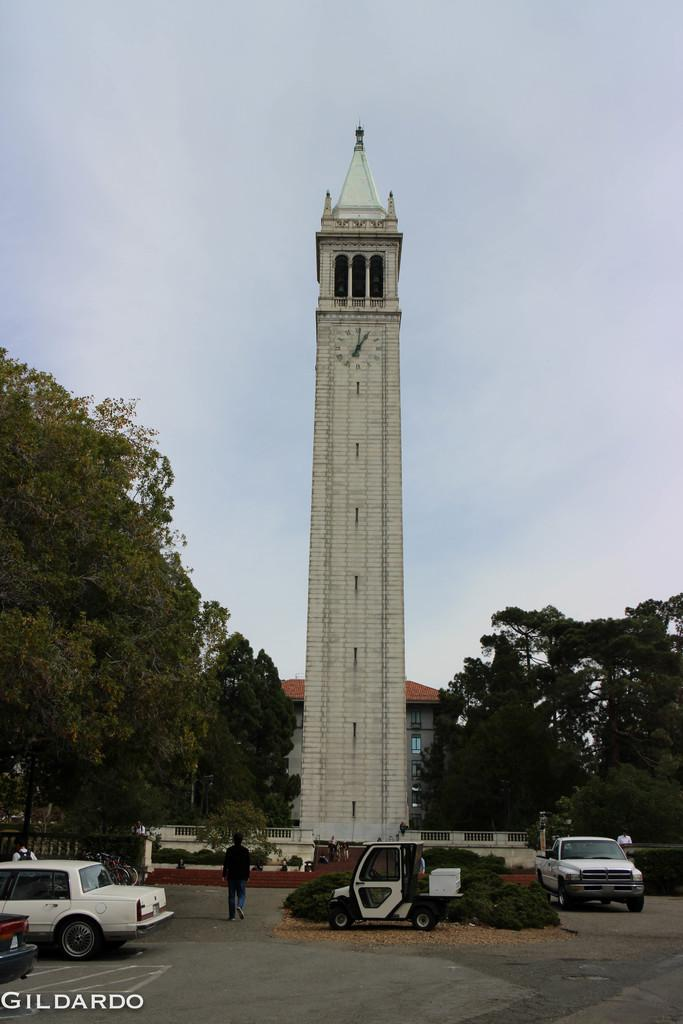What types of vehicles can be seen in the image? There are vehicles in the image, but the specific types are not mentioned. Can you describe the people in the image? There are people in the image, but their actions or characteristics are not mentioned. What is located on the road in the image? There are bushes on the road in the image. What type of barrier is present in the image? There is fencing in the image. What tall structure is visible in the image? There is a clock tower in the image. What type of vegetation is present in the image? There are trees in the image. What type of structure is present in the image? There is a building in the image. What other objects can be seen in the image? There are other objects in the image, but their specific types are not mentioned. What part of the natural environment is visible in the image? The sky is visible in the image. What type of cast can be seen on the arm of the person in the image? There is no mention of a cast or any injuries in the image. What type of observation can be made about the behavior of the vehicles in the image? The behavior of the vehicles is not mentioned in the image, so no observation can be made. 